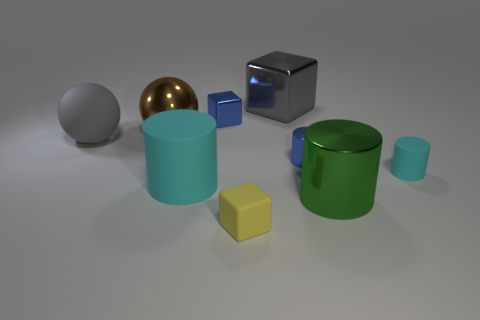How many other objects are the same color as the tiny rubber block?
Offer a very short reply. 0. Are there any other things that have the same size as the gray matte sphere?
Offer a very short reply. Yes. What number of other things are there of the same shape as the small cyan rubber thing?
Provide a short and direct response. 3. Is the size of the brown metal sphere the same as the blue shiny cylinder?
Make the answer very short. No. Are any blue cylinders visible?
Offer a terse response. Yes. Is there anything else that is the same material as the large gray cube?
Offer a very short reply. Yes. Is there another large green cylinder made of the same material as the big green cylinder?
Your answer should be compact. No. There is a cyan object that is the same size as the blue metal cylinder; what material is it?
Ensure brevity in your answer.  Rubber. What number of small cyan things have the same shape as the yellow thing?
Provide a succinct answer. 0. What is the size of the green object that is the same material as the gray cube?
Your answer should be very brief. Large. 